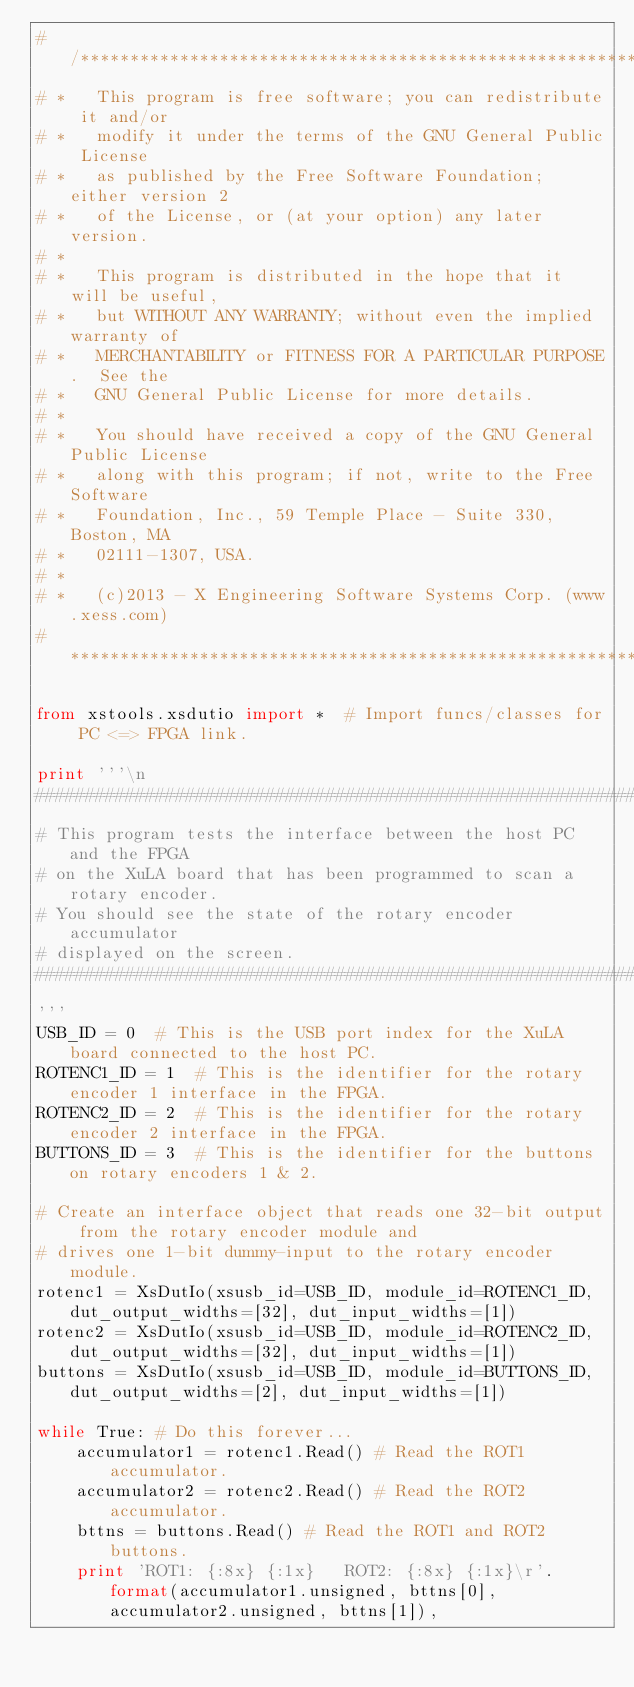Convert code to text. <code><loc_0><loc_0><loc_500><loc_500><_Python_># /***********************************************************************************
# *   This program is free software; you can redistribute it and/or
# *   modify it under the terms of the GNU General Public License
# *   as published by the Free Software Foundation; either version 2
# *   of the License, or (at your option) any later version.
# *
# *   This program is distributed in the hope that it will be useful,
# *   but WITHOUT ANY WARRANTY; without even the implied warranty of
# *   MERCHANTABILITY or FITNESS FOR A PARTICULAR PURPOSE.  See the
# *   GNU General Public License for more details.
# *
# *   You should have received a copy of the GNU General Public License
# *   along with this program; if not, write to the Free Software
# *   Foundation, Inc., 59 Temple Place - Suite 330, Boston, MA
# *   02111-1307, USA.
# *
# *   (c)2013 - X Engineering Software Systems Corp. (www.xess.com)
# ***********************************************************************************/

from xstools.xsdutio import *  # Import funcs/classes for PC <=> FPGA link.

print '''\n
##################################################################
# This program tests the interface between the host PC and the FPGA 
# on the XuLA board that has been programmed to scan a rotary encoder.
# You should see the state of the rotary encoder accumulator
# displayed on the screen.
##################################################################
'''
USB_ID = 0  # This is the USB port index for the XuLA board connected to the host PC.
ROTENC1_ID = 1  # This is the identifier for the rotary encoder 1 interface in the FPGA.
ROTENC2_ID = 2  # This is the identifier for the rotary encoder 2 interface in the FPGA.
BUTTONS_ID = 3  # This is the identifier for the buttons on rotary encoders 1 & 2.

# Create an interface object that reads one 32-bit output from the rotary encoder module and
# drives one 1-bit dummy-input to the rotary encoder module.
rotenc1 = XsDutIo(xsusb_id=USB_ID, module_id=ROTENC1_ID, dut_output_widths=[32], dut_input_widths=[1])
rotenc2 = XsDutIo(xsusb_id=USB_ID, module_id=ROTENC2_ID, dut_output_widths=[32], dut_input_widths=[1])
buttons = XsDutIo(xsusb_id=USB_ID, module_id=BUTTONS_ID, dut_output_widths=[2], dut_input_widths=[1])

while True: # Do this forever...
    accumulator1 = rotenc1.Read() # Read the ROT1 accumulator.
    accumulator2 = rotenc2.Read() # Read the ROT2 accumulator.
    bttns = buttons.Read() # Read the ROT1 and ROT2 buttons.
    print 'ROT1: {:8x} {:1x}   ROT2: {:8x} {:1x}\r'.format(accumulator1.unsigned, bttns[0], accumulator2.unsigned, bttns[1]),
</code> 